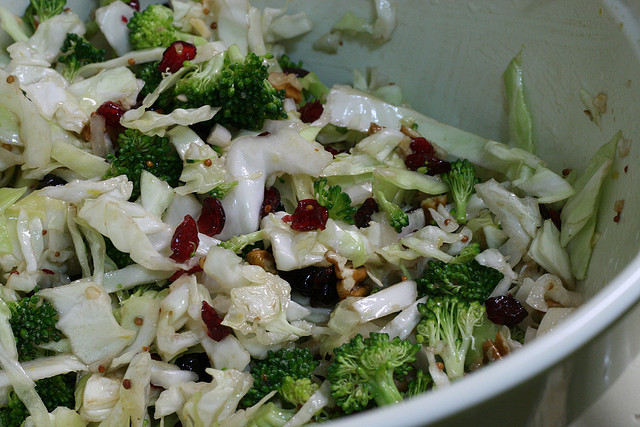<image>Who left the mess on the plate? It is unknown who left the mess on the plate. It could be the chef, a child, a mom, or just someone. Who left the mess on the plate? I am not sure who left the mess on the plate. It could be the chef, someone, child, or person who made it. 